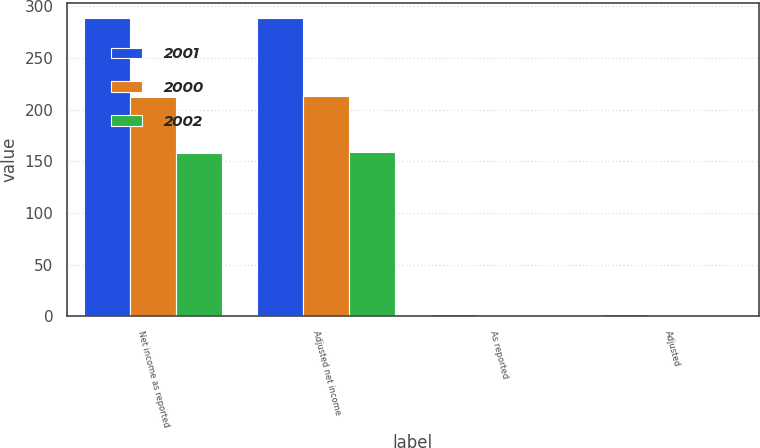Convert chart. <chart><loc_0><loc_0><loc_500><loc_500><stacked_bar_chart><ecel><fcel>Net income as reported<fcel>Adjusted net income<fcel>As reported<fcel>Adjusted<nl><fcel>2001<fcel>288.9<fcel>288.9<fcel>1.88<fcel>1.88<nl><fcel>2000<fcel>212.2<fcel>213.4<fcel>1.35<fcel>1.35<nl><fcel>2002<fcel>158.5<fcel>159.3<fcel>0.98<fcel>0.99<nl></chart> 